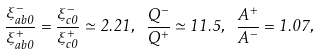Convert formula to latex. <formula><loc_0><loc_0><loc_500><loc_500>\frac { \xi _ { a b 0 } ^ { - } } { \xi _ { a b 0 } ^ { + } } = \frac { \xi _ { c 0 } ^ { - } } { \xi _ { c 0 } ^ { + } } \simeq 2 . 2 1 , \text { } \frac { Q ^ { - } } { Q ^ { + } } \simeq 1 1 . 5 , \text { } \frac { A ^ { + } } { A ^ { - } } = 1 . 0 7 ,</formula> 